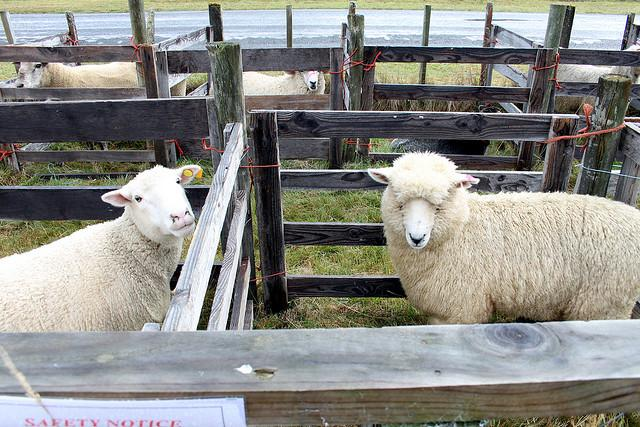What color is the twine that is tied between the cages carrying sheep? red 